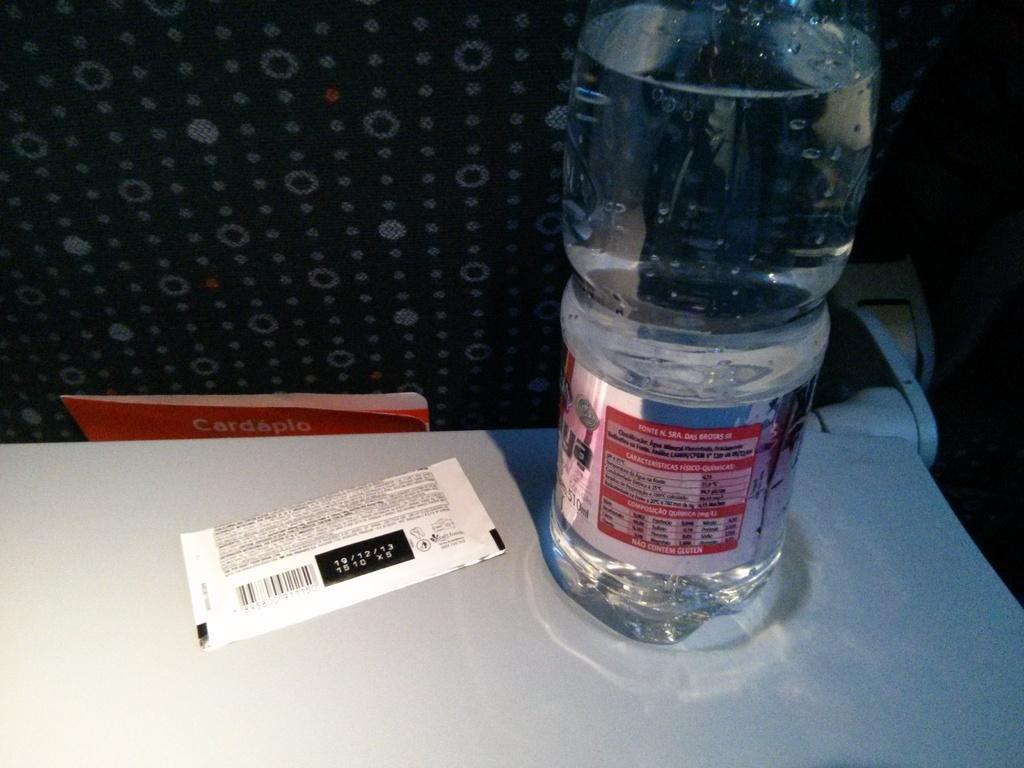What is one of the items visible in the image? There is a water bottle in the image. What other item can be seen in the image? There is a chocolate in the image. Where are the water bottle and chocolate located? Both items are placed on a table. What can be seen in the background of the image? There is a wall in the background of the image. What type of bucket is used to rest on the table in the image? There is no bucket present in the image; it only features a water bottle and chocolate on a table. 